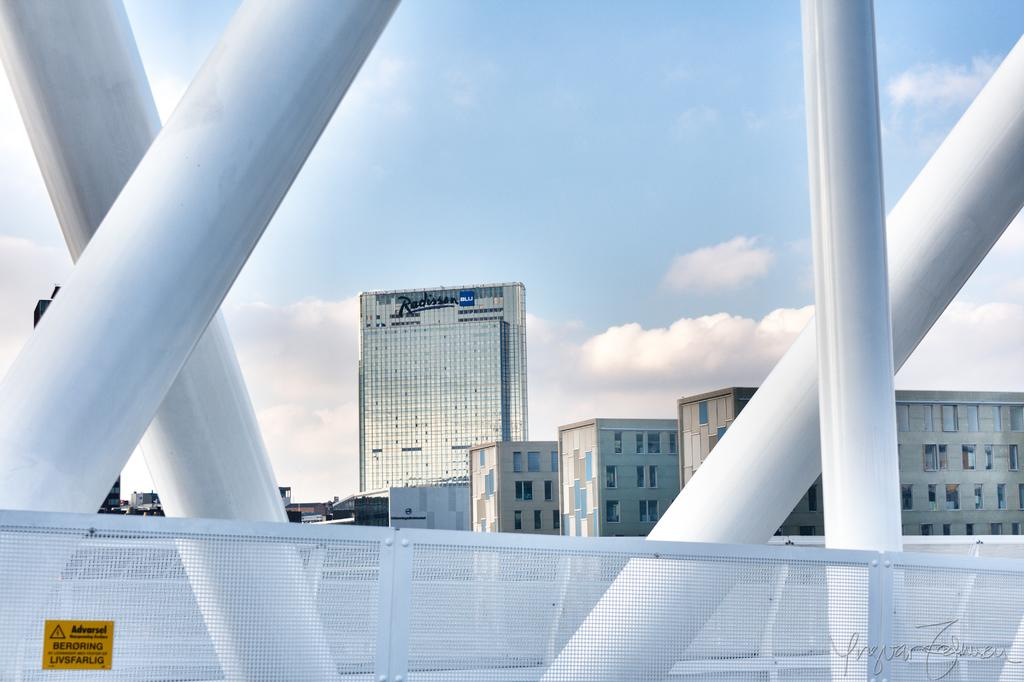<image>
Present a compact description of the photo's key features. buildings across from a bridge with one that says 'radisson blu' on it 